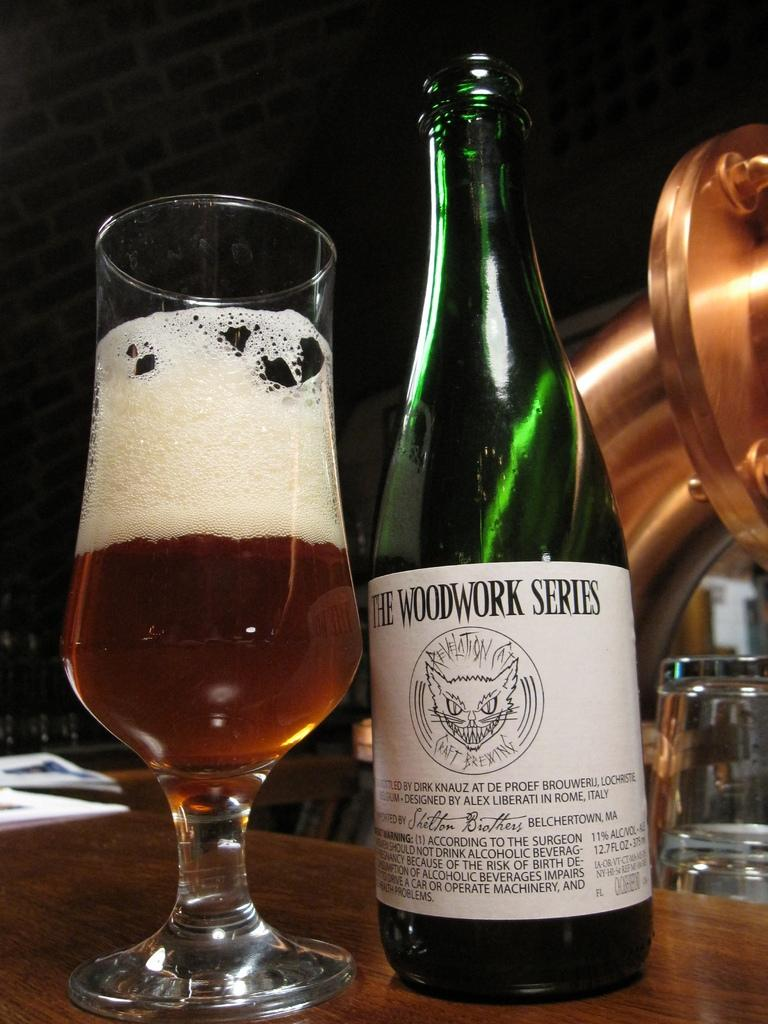<image>
Summarize the visual content of the image. Green bottle with a white lable that says "The Woodwork Series". 